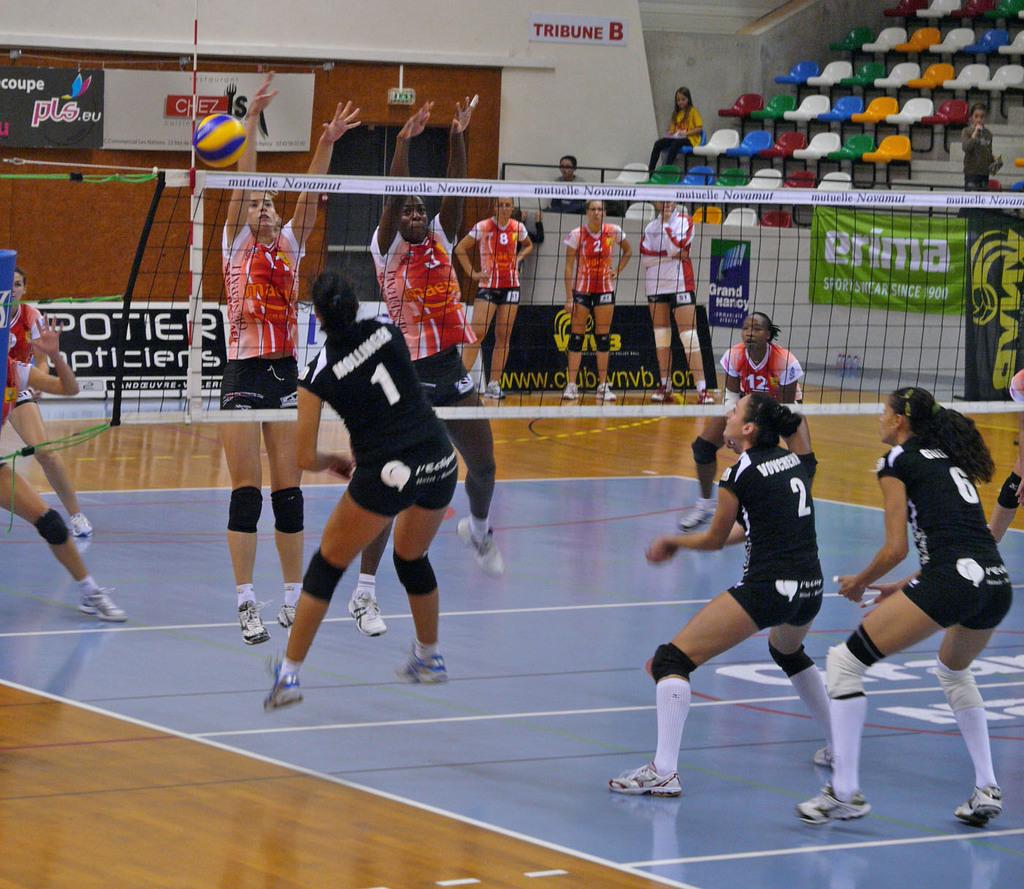What is written across the top portion of the net?
Keep it short and to the point. Mutuelle novamut. Is player 1 on the court?
Provide a succinct answer. Yes. 